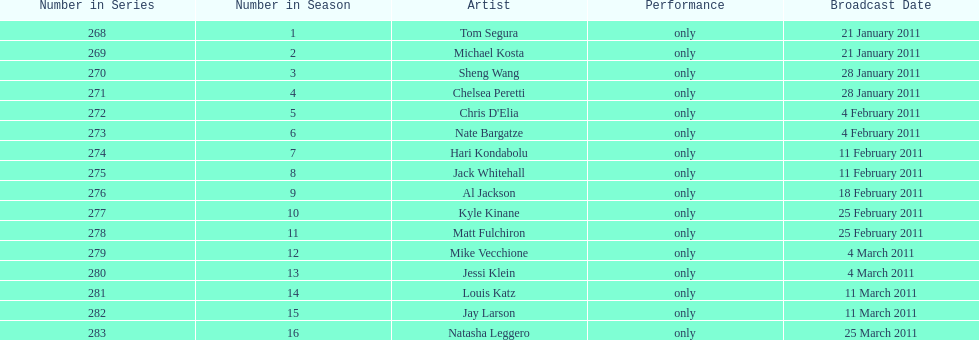How many performers appeared on the air date 21 january 2011? 2. 